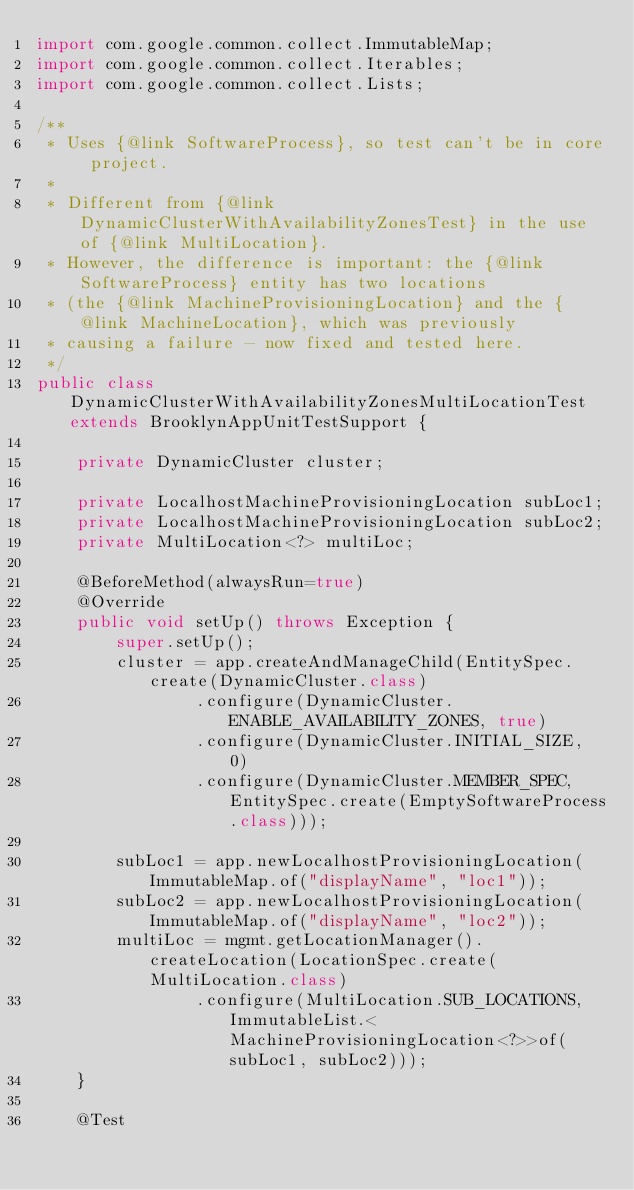<code> <loc_0><loc_0><loc_500><loc_500><_Java_>import com.google.common.collect.ImmutableMap;
import com.google.common.collect.Iterables;
import com.google.common.collect.Lists;

/**
 * Uses {@link SoftwareProcess}, so test can't be in core project.
 * 
 * Different from {@link DynamicClusterWithAvailabilityZonesTest} in the use of {@link MultiLocation}.
 * However, the difference is important: the {@link SoftwareProcess} entity has two locations
 * (the {@link MachineProvisioningLocation} and the {@link MachineLocation}, which was previously
 * causing a failure - now fixed and tested here.
 */
public class DynamicClusterWithAvailabilityZonesMultiLocationTest extends BrooklynAppUnitTestSupport {
    
    private DynamicCluster cluster;
    
    private LocalhostMachineProvisioningLocation subLoc1;
    private LocalhostMachineProvisioningLocation subLoc2;
    private MultiLocation<?> multiLoc;
    
    @BeforeMethod(alwaysRun=true)
    @Override
    public void setUp() throws Exception {
        super.setUp();
        cluster = app.createAndManageChild(EntitySpec.create(DynamicCluster.class)
                .configure(DynamicCluster.ENABLE_AVAILABILITY_ZONES, true)
                .configure(DynamicCluster.INITIAL_SIZE, 0)
                .configure(DynamicCluster.MEMBER_SPEC, EntitySpec.create(EmptySoftwareProcess.class)));
        
        subLoc1 = app.newLocalhostProvisioningLocation(ImmutableMap.of("displayName", "loc1"));
        subLoc2 = app.newLocalhostProvisioningLocation(ImmutableMap.of("displayName", "loc2"));
        multiLoc = mgmt.getLocationManager().createLocation(LocationSpec.create(MultiLocation.class)
                .configure(MultiLocation.SUB_LOCATIONS, ImmutableList.<MachineProvisioningLocation<?>>of(subLoc1, subLoc2)));
    }

    @Test</code> 